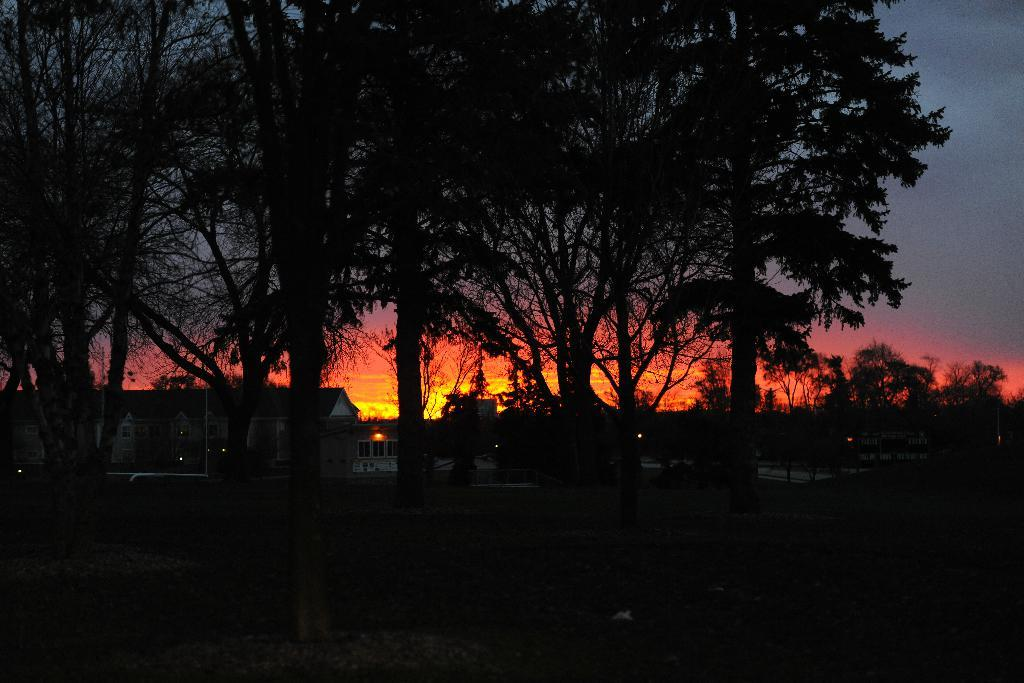What type of natural elements can be seen in the image? There are trees in the image. What type of man-made structures are present in the image? There are houses in the image. What part of the natural environment is visible in the image? The sky is visible in the image. Can you describe the lighting conditions in the image? The image appears to be slightly dark. How many servants are visible in the image? There are no servants present in the image. What type of clouds can be seen in the image? There is no mention of clouds in the provided facts, and therefore we cannot determine if any are present in the image. 